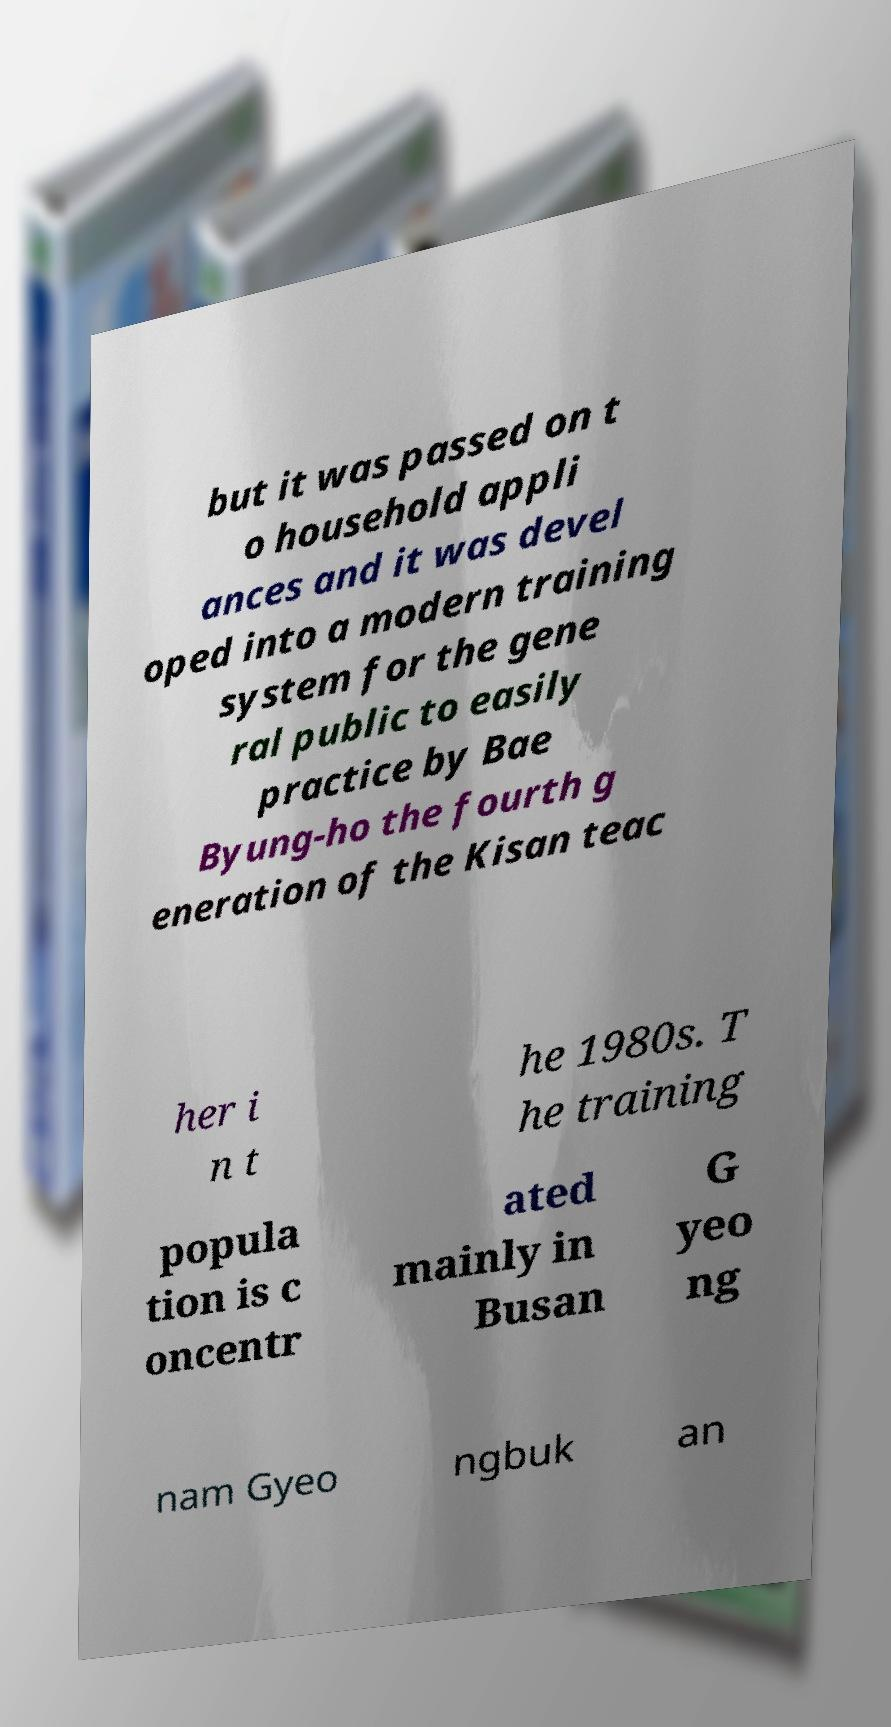Please read and relay the text visible in this image. What does it say? but it was passed on t o household appli ances and it was devel oped into a modern training system for the gene ral public to easily practice by Bae Byung-ho the fourth g eneration of the Kisan teac her i n t he 1980s. T he training popula tion is c oncentr ated mainly in Busan G yeo ng nam Gyeo ngbuk an 